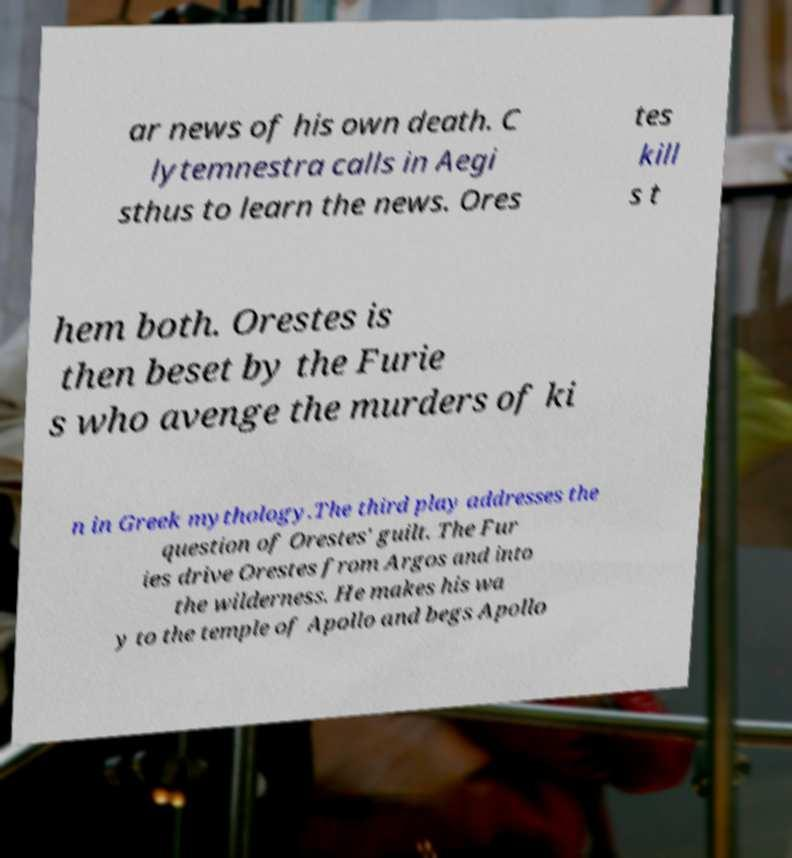Can you accurately transcribe the text from the provided image for me? ar news of his own death. C lytemnestra calls in Aegi sthus to learn the news. Ores tes kill s t hem both. Orestes is then beset by the Furie s who avenge the murders of ki n in Greek mythology.The third play addresses the question of Orestes' guilt. The Fur ies drive Orestes from Argos and into the wilderness. He makes his wa y to the temple of Apollo and begs Apollo 